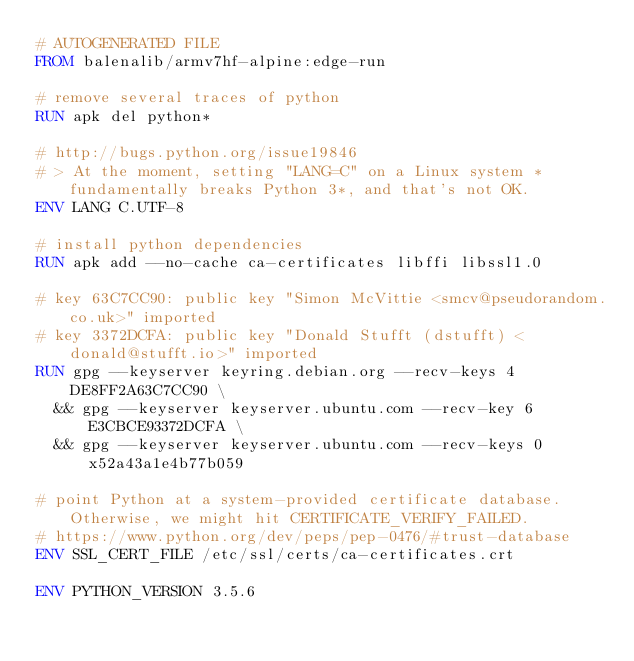<code> <loc_0><loc_0><loc_500><loc_500><_Dockerfile_># AUTOGENERATED FILE
FROM balenalib/armv7hf-alpine:edge-run

# remove several traces of python
RUN apk del python*

# http://bugs.python.org/issue19846
# > At the moment, setting "LANG=C" on a Linux system *fundamentally breaks Python 3*, and that's not OK.
ENV LANG C.UTF-8

# install python dependencies
RUN apk add --no-cache ca-certificates libffi libssl1.0

# key 63C7CC90: public key "Simon McVittie <smcv@pseudorandom.co.uk>" imported
# key 3372DCFA: public key "Donald Stufft (dstufft) <donald@stufft.io>" imported
RUN gpg --keyserver keyring.debian.org --recv-keys 4DE8FF2A63C7CC90 \
	&& gpg --keyserver keyserver.ubuntu.com --recv-key 6E3CBCE93372DCFA \
	&& gpg --keyserver keyserver.ubuntu.com --recv-keys 0x52a43a1e4b77b059

# point Python at a system-provided certificate database. Otherwise, we might hit CERTIFICATE_VERIFY_FAILED.
# https://www.python.org/dev/peps/pep-0476/#trust-database
ENV SSL_CERT_FILE /etc/ssl/certs/ca-certificates.crt

ENV PYTHON_VERSION 3.5.6
</code> 